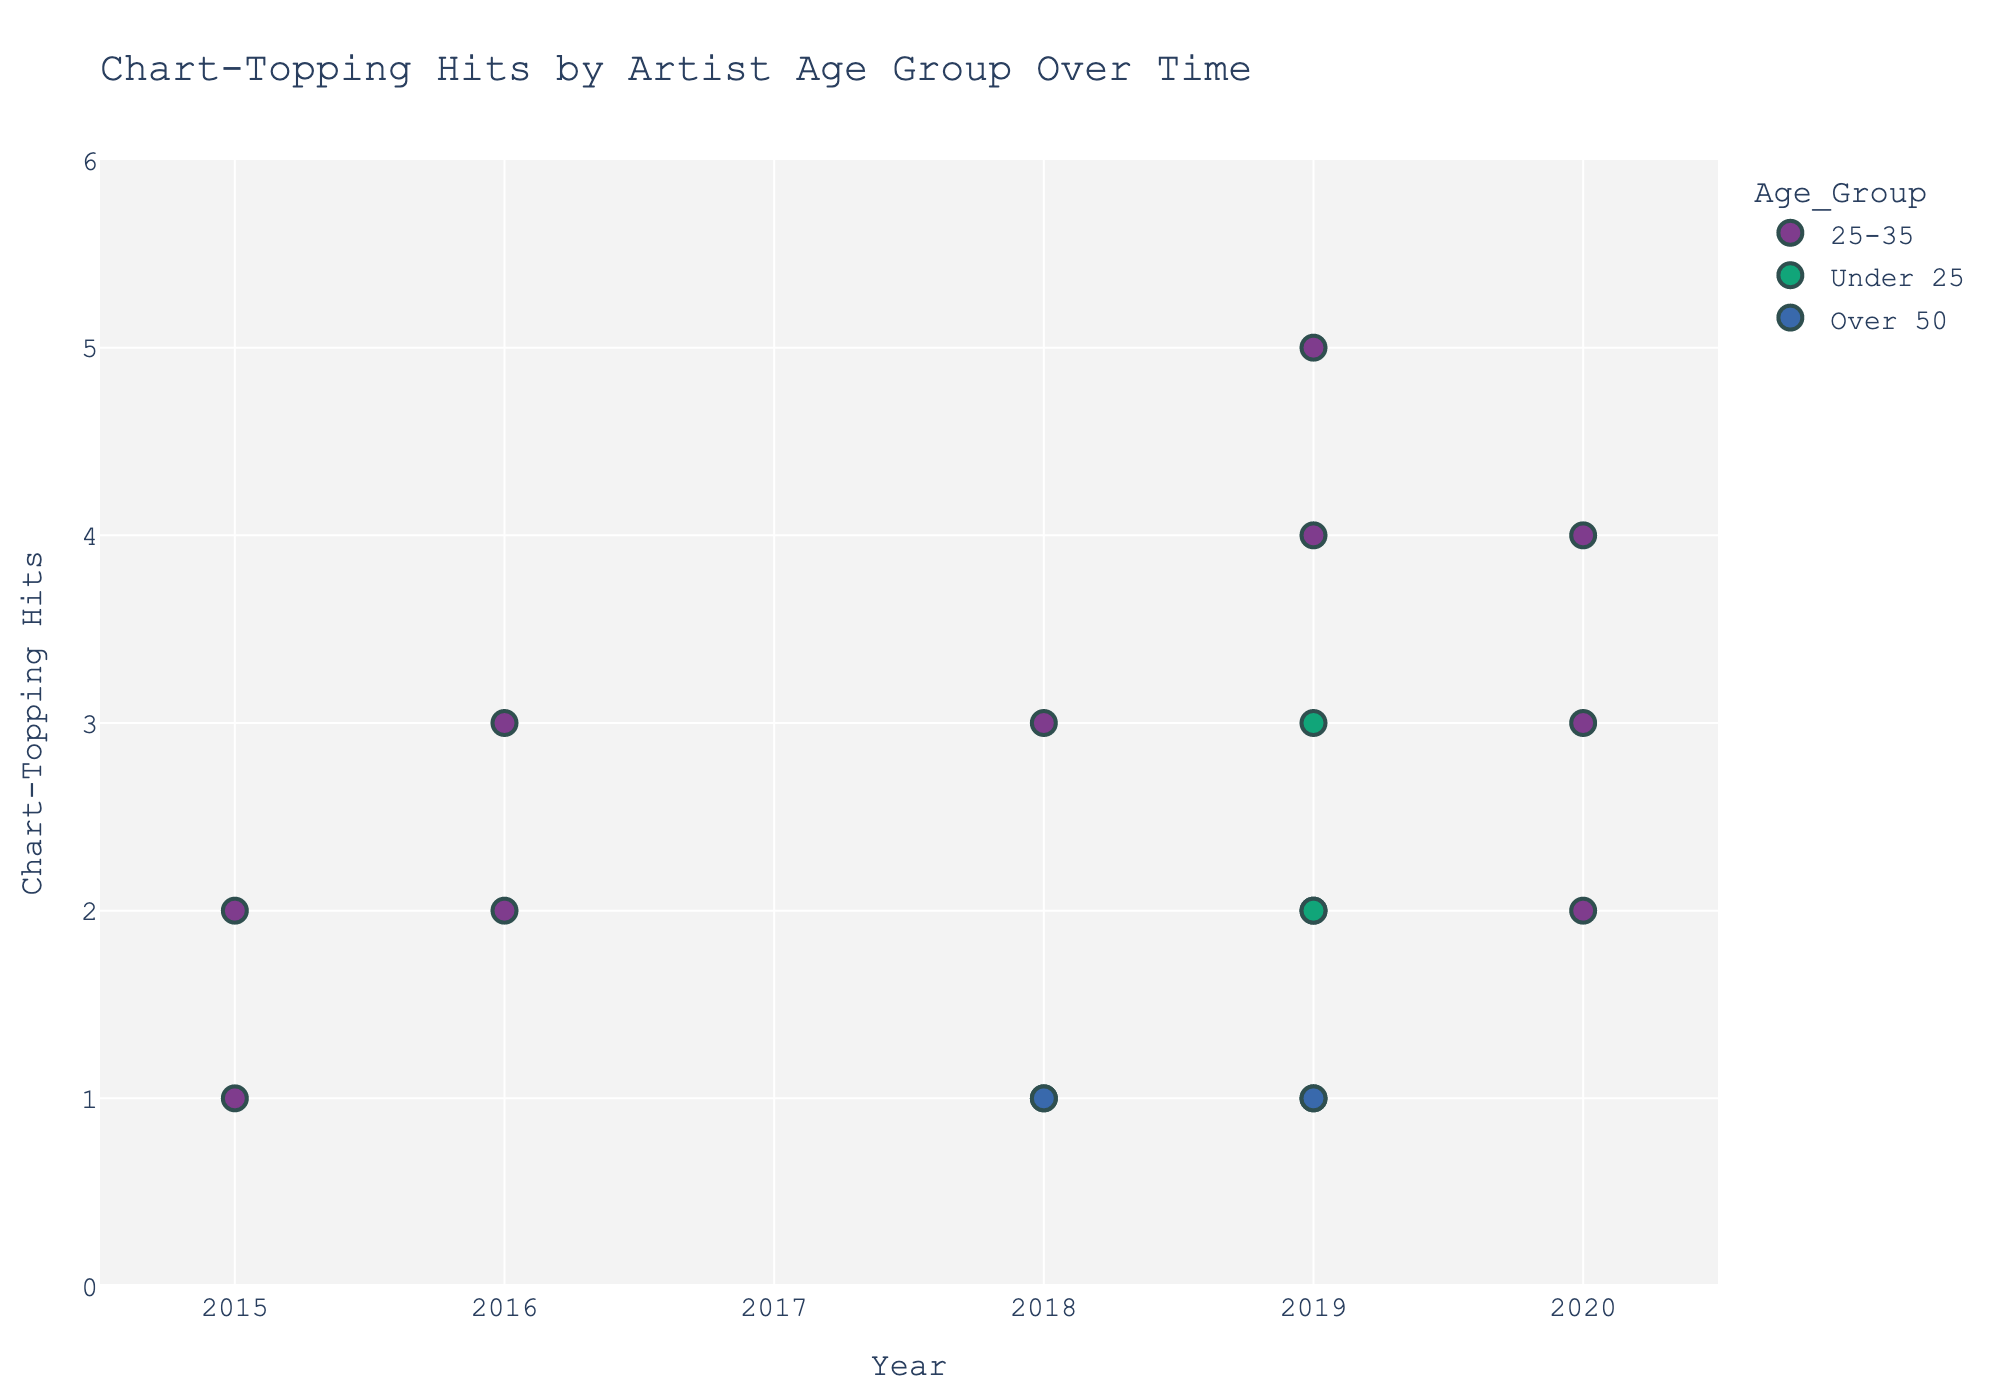What is the title of the scatter plot? To find the title, look at the top-center of the figure where it is usually displayed. It summarizes the main idea of the chart.
Answer: Chart-Topping Hits by Artist Age Group Over Time Which age group had the most number of chart-topping hits in 2019? To answer this, check the color-coded dots for the year 2019. Compare the sizes of dots within the same year and identify which age group had the largest dot.
Answer: 25-35 How many chart-topping hits did Ariana Grande have in 2019? Look for the dot in the 2019 section where Ariana Grande's name is displayed in the hover information. Note the size of the dot or the exact number if visible in the hover data.
Answer: 5 Compare the number of chart-topping hits by Taylor Swift and The Weeknd in 2020. Who had more? Locate the dots for Taylor Swift and The Weeknd in the year 2020. Check the sizes of the dots and the hover information to see their number of hits, then compare them.
Answer: The Weeknd Which artist had the highest number of chart-topping hits in 2019 and what was their age group? Look through the dots in 2019, find the largest one for that year, and check the hover information for the artist's name and age group.
Answer: Ariana Grande, 25-35 In which year did the most artists from the 'Under 25' age group achieve chart-topping hits? Check the color-coded dots for 'Under 25' across all years. Count the number of dots in each year to determine which year has the most.
Answer: 2019 What is the maximum number of chart-topping hits achieved by an artist over the time span shown? Locate the largest dot within the entire plot and note its numerical value by hovering over it.
Answer: 5 Who are the artists in the 'Over 50' age group and how many chart-topping hits did they have? Scan for dots in the color corresponding to the 'Over 50' age group. Check the hover information for the artists' names and their number of hits.
Answer: Elton John (1), Paul McCartney (1), Madonna (1) How many artists had exactly 3 chart-topping hits in 2019? Identify the dots in the year 2019, and count how many have the size or numerical value indicating 3 hits based on the hover information.
Answer: 2 (Ed Sheeran, Justin Bieber) 